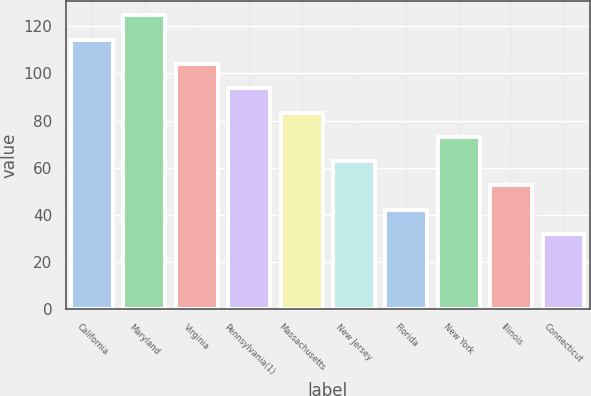Convert chart. <chart><loc_0><loc_0><loc_500><loc_500><bar_chart><fcel>California<fcel>Maryland<fcel>Virginia<fcel>Pennsylvania(1)<fcel>Massachusetts<fcel>New Jersey<fcel>Florida<fcel>New York<fcel>Illinois<fcel>Connecticut<nl><fcel>114.3<fcel>124.6<fcel>104<fcel>93.7<fcel>83.4<fcel>62.8<fcel>42.2<fcel>73.1<fcel>52.5<fcel>31.9<nl></chart> 